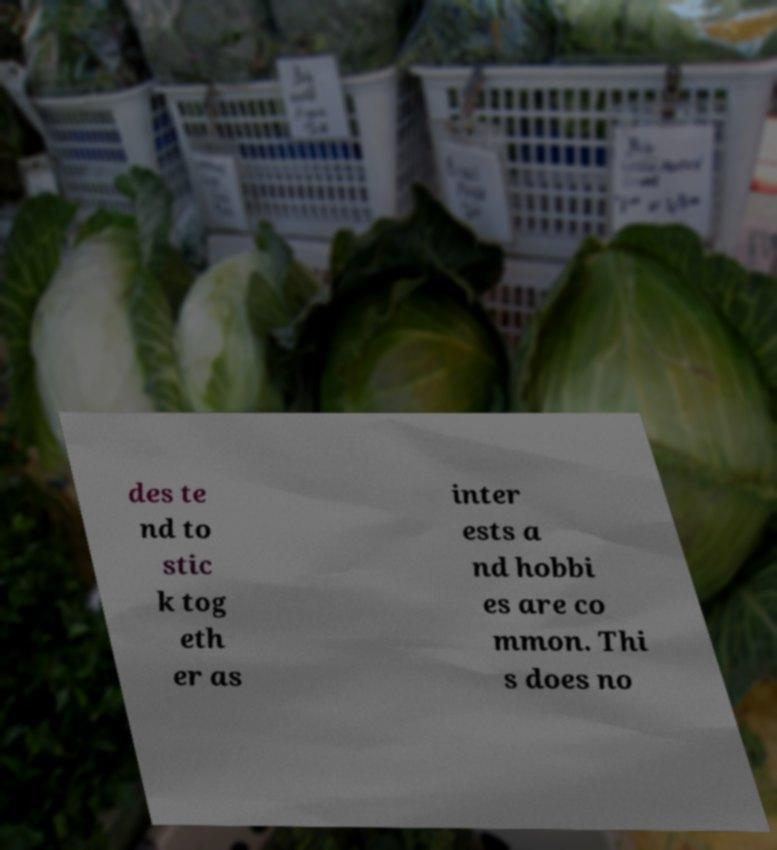Could you assist in decoding the text presented in this image and type it out clearly? des te nd to stic k tog eth er as inter ests a nd hobbi es are co mmon. Thi s does no 